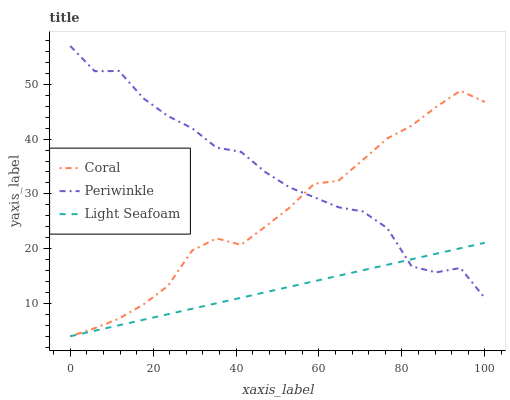Does Light Seafoam have the minimum area under the curve?
Answer yes or no. Yes. Does Periwinkle have the maximum area under the curve?
Answer yes or no. Yes. Does Periwinkle have the minimum area under the curve?
Answer yes or no. No. Does Light Seafoam have the maximum area under the curve?
Answer yes or no. No. Is Light Seafoam the smoothest?
Answer yes or no. Yes. Is Periwinkle the roughest?
Answer yes or no. Yes. Is Periwinkle the smoothest?
Answer yes or no. No. Is Light Seafoam the roughest?
Answer yes or no. No. Does Coral have the lowest value?
Answer yes or no. Yes. Does Periwinkle have the lowest value?
Answer yes or no. No. Does Periwinkle have the highest value?
Answer yes or no. Yes. Does Light Seafoam have the highest value?
Answer yes or no. No. Does Periwinkle intersect Coral?
Answer yes or no. Yes. Is Periwinkle less than Coral?
Answer yes or no. No. Is Periwinkle greater than Coral?
Answer yes or no. No. 